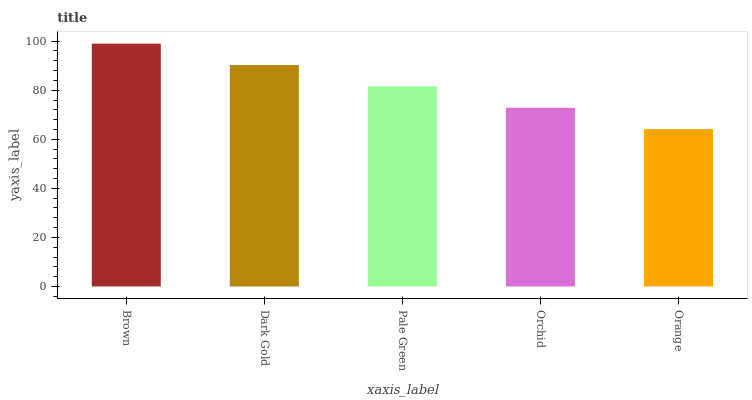Is Orange the minimum?
Answer yes or no. Yes. Is Brown the maximum?
Answer yes or no. Yes. Is Dark Gold the minimum?
Answer yes or no. No. Is Dark Gold the maximum?
Answer yes or no. No. Is Brown greater than Dark Gold?
Answer yes or no. Yes. Is Dark Gold less than Brown?
Answer yes or no. Yes. Is Dark Gold greater than Brown?
Answer yes or no. No. Is Brown less than Dark Gold?
Answer yes or no. No. Is Pale Green the high median?
Answer yes or no. Yes. Is Pale Green the low median?
Answer yes or no. Yes. Is Orchid the high median?
Answer yes or no. No. Is Orange the low median?
Answer yes or no. No. 